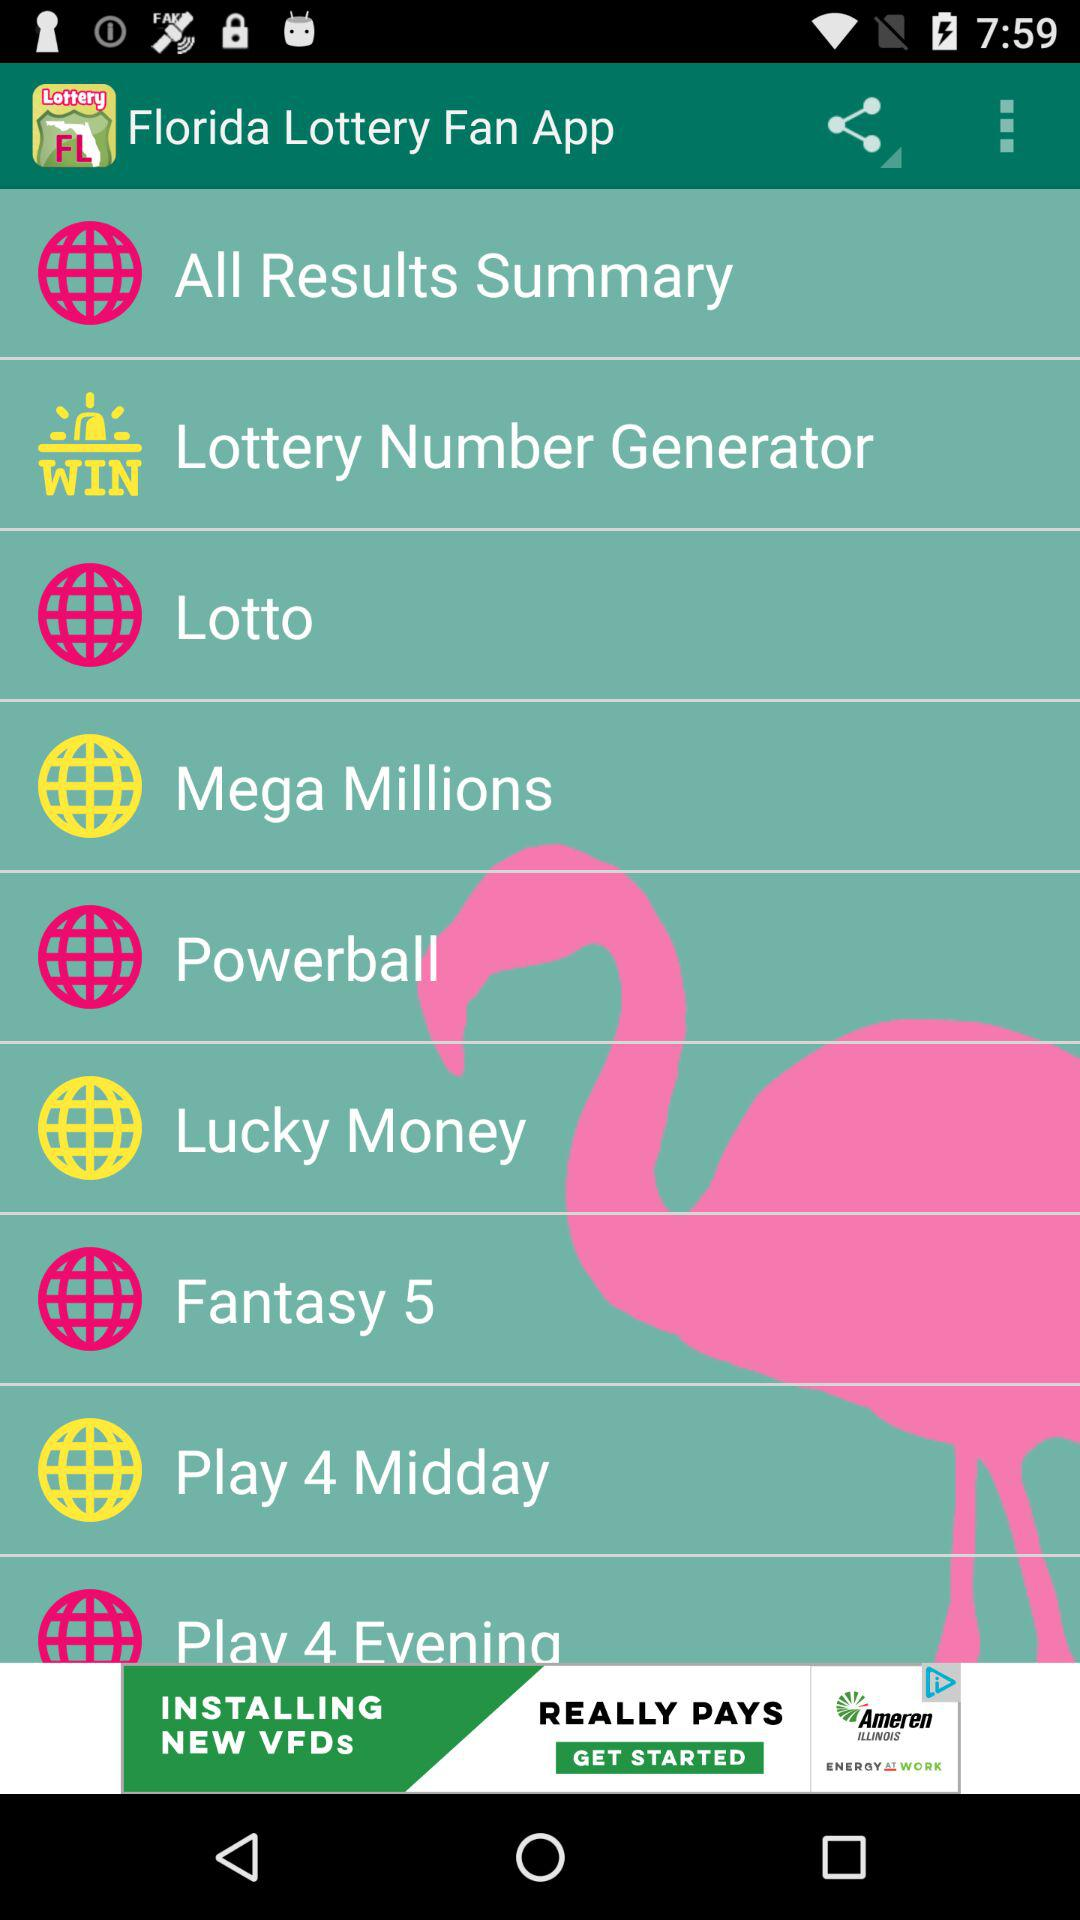What is the name of the application? The name of the application is "Florida Lottery Fan". 